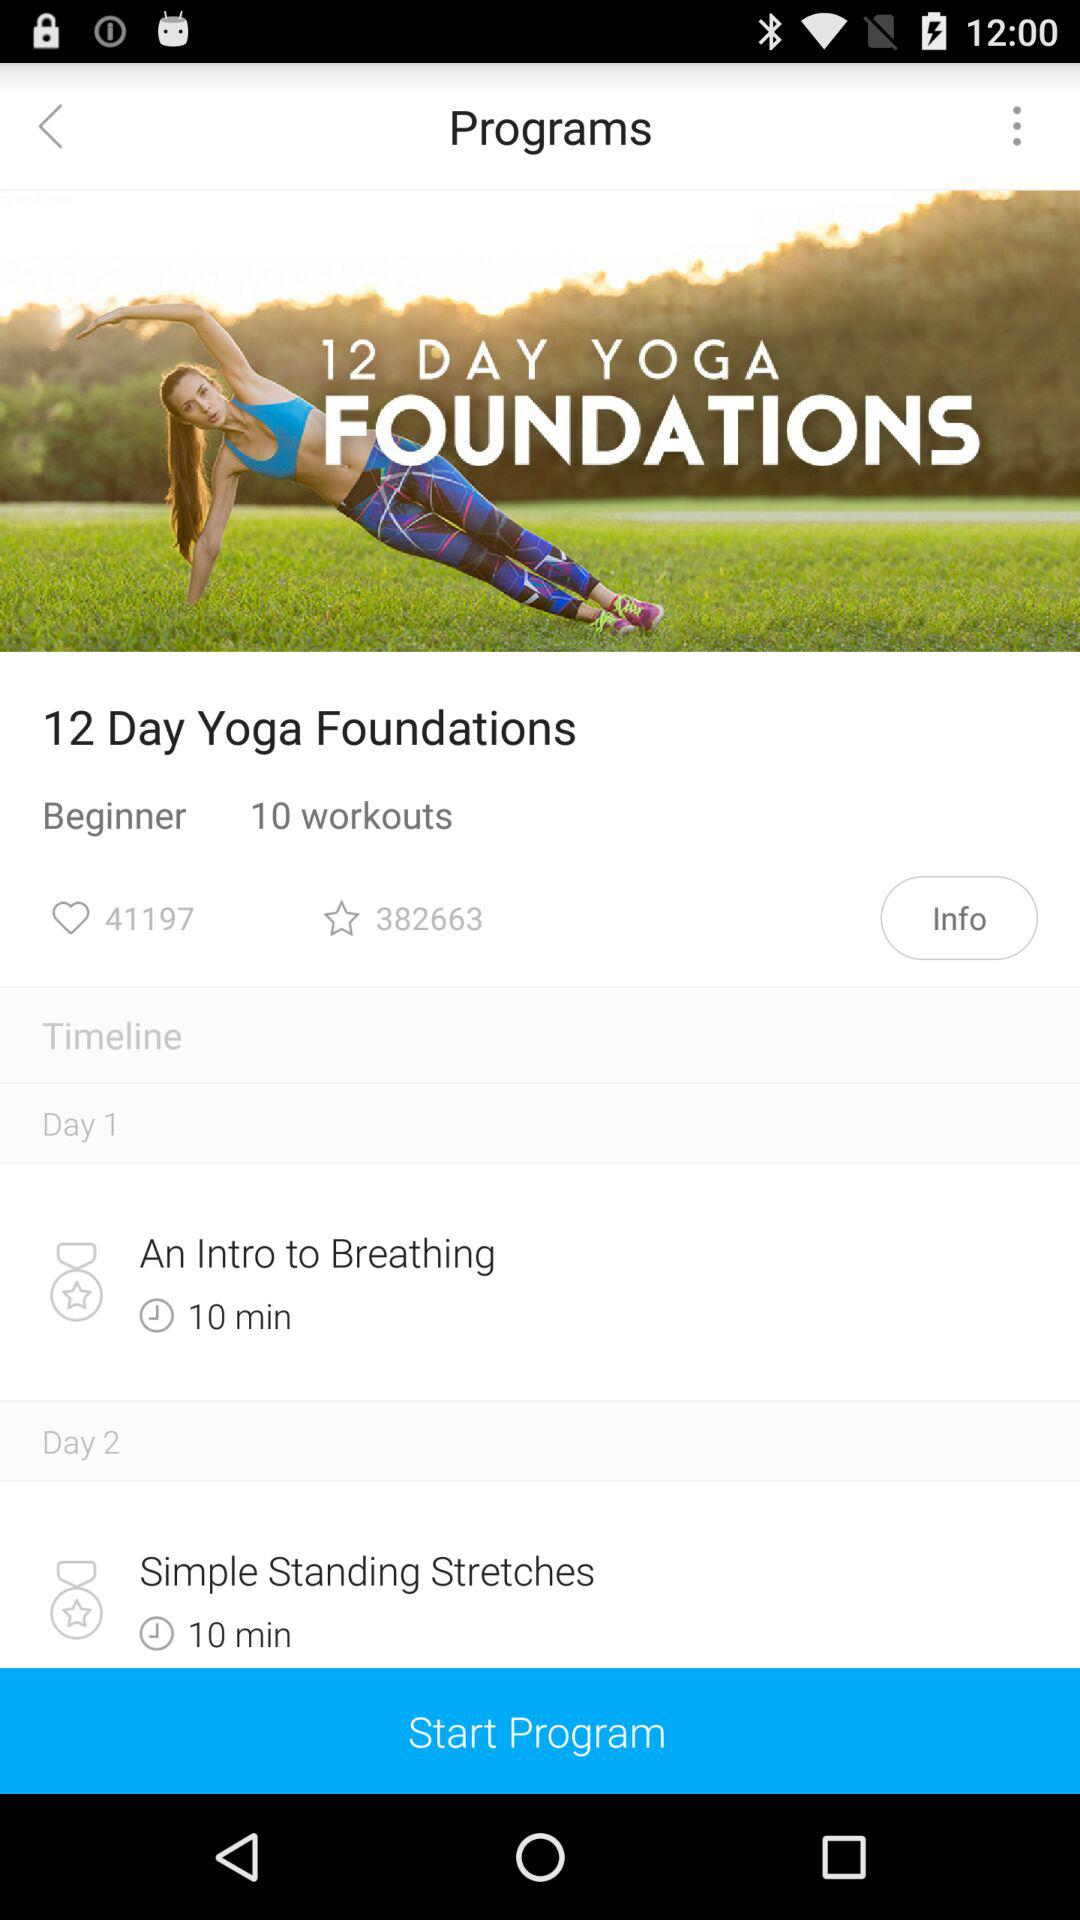What is the name of the program? The name of the program is "12 Day Yoga Foundations". 